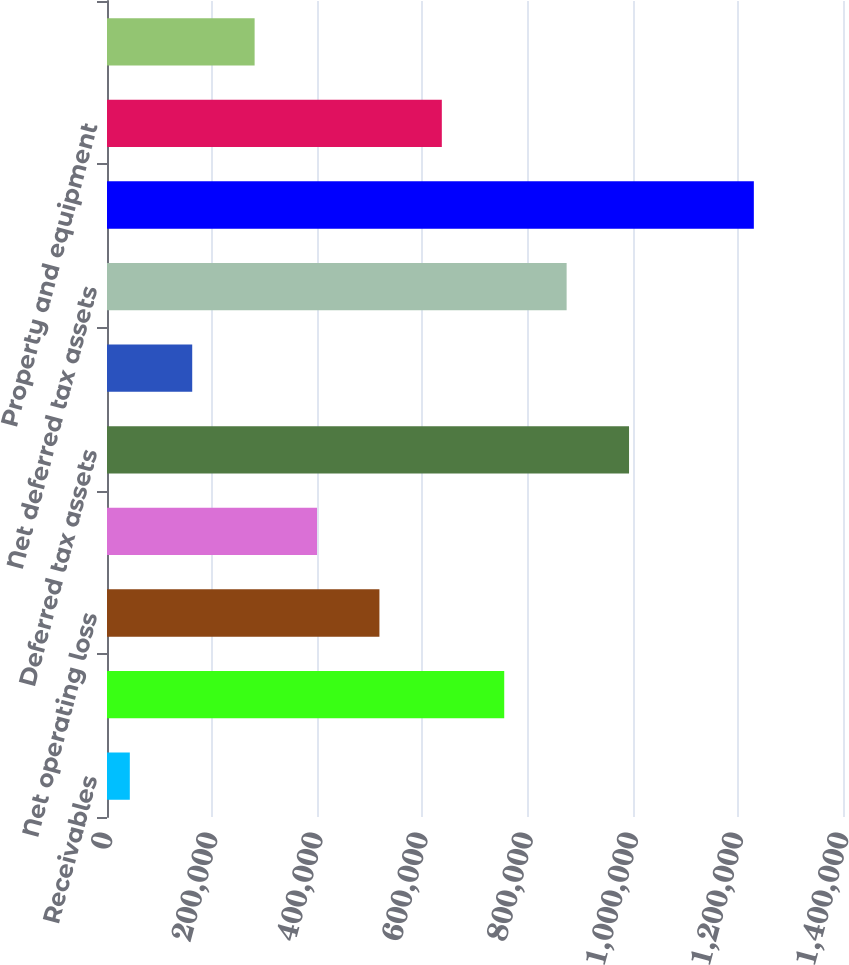Convert chart. <chart><loc_0><loc_0><loc_500><loc_500><bar_chart><fcel>Receivables<fcel>Accrued liabilities<fcel>Net operating loss<fcel>Other<fcel>Deferred tax assets<fcel>Valuation allowance<fcel>Net deferred tax assets<fcel>Intangible assets<fcel>Property and equipment<fcel>Investments in partnerships<nl><fcel>43393<fcel>755601<fcel>518198<fcel>399497<fcel>993003<fcel>162094<fcel>874302<fcel>1.23041e+06<fcel>636900<fcel>280796<nl></chart> 